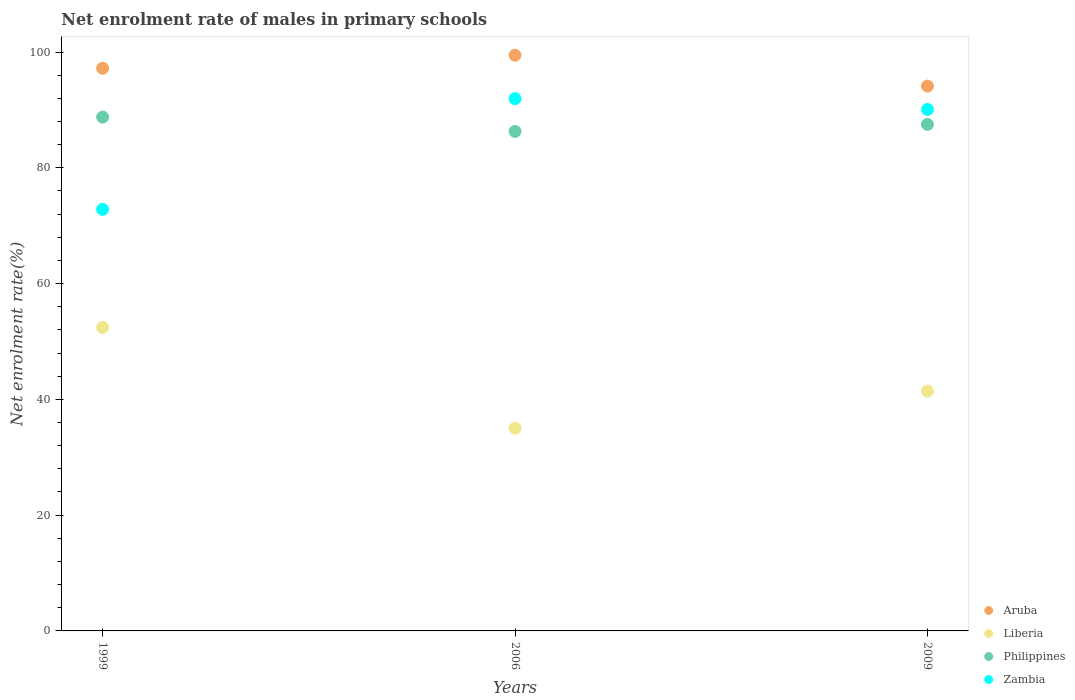How many different coloured dotlines are there?
Ensure brevity in your answer.  4. What is the net enrolment rate of males in primary schools in Liberia in 2009?
Provide a succinct answer. 41.44. Across all years, what is the maximum net enrolment rate of males in primary schools in Zambia?
Ensure brevity in your answer.  91.95. Across all years, what is the minimum net enrolment rate of males in primary schools in Liberia?
Give a very brief answer. 35.02. What is the total net enrolment rate of males in primary schools in Liberia in the graph?
Keep it short and to the point. 128.89. What is the difference between the net enrolment rate of males in primary schools in Zambia in 2006 and that in 2009?
Make the answer very short. 1.86. What is the difference between the net enrolment rate of males in primary schools in Liberia in 1999 and the net enrolment rate of males in primary schools in Zambia in 2009?
Your answer should be compact. -37.65. What is the average net enrolment rate of males in primary schools in Aruba per year?
Give a very brief answer. 96.93. In the year 1999, what is the difference between the net enrolment rate of males in primary schools in Zambia and net enrolment rate of males in primary schools in Aruba?
Your answer should be compact. -24.37. In how many years, is the net enrolment rate of males in primary schools in Aruba greater than 28 %?
Your response must be concise. 3. What is the ratio of the net enrolment rate of males in primary schools in Aruba in 2006 to that in 2009?
Offer a very short reply. 1.06. Is the net enrolment rate of males in primary schools in Philippines in 1999 less than that in 2006?
Your response must be concise. No. Is the difference between the net enrolment rate of males in primary schools in Zambia in 2006 and 2009 greater than the difference between the net enrolment rate of males in primary schools in Aruba in 2006 and 2009?
Your answer should be very brief. No. What is the difference between the highest and the second highest net enrolment rate of males in primary schools in Zambia?
Make the answer very short. 1.86. What is the difference between the highest and the lowest net enrolment rate of males in primary schools in Liberia?
Offer a very short reply. 17.41. Is it the case that in every year, the sum of the net enrolment rate of males in primary schools in Liberia and net enrolment rate of males in primary schools in Philippines  is greater than the sum of net enrolment rate of males in primary schools in Zambia and net enrolment rate of males in primary schools in Aruba?
Your response must be concise. No. Is the net enrolment rate of males in primary schools in Philippines strictly greater than the net enrolment rate of males in primary schools in Liberia over the years?
Your response must be concise. Yes. How many years are there in the graph?
Make the answer very short. 3. What is the difference between two consecutive major ticks on the Y-axis?
Provide a succinct answer. 20. Are the values on the major ticks of Y-axis written in scientific E-notation?
Make the answer very short. No. Does the graph contain grids?
Make the answer very short. No. Where does the legend appear in the graph?
Give a very brief answer. Bottom right. How many legend labels are there?
Your answer should be very brief. 4. What is the title of the graph?
Ensure brevity in your answer.  Net enrolment rate of males in primary schools. Does "American Samoa" appear as one of the legend labels in the graph?
Your answer should be very brief. No. What is the label or title of the X-axis?
Your answer should be compact. Years. What is the label or title of the Y-axis?
Give a very brief answer. Net enrolment rate(%). What is the Net enrolment rate(%) of Aruba in 1999?
Ensure brevity in your answer.  97.2. What is the Net enrolment rate(%) in Liberia in 1999?
Make the answer very short. 52.43. What is the Net enrolment rate(%) in Philippines in 1999?
Your answer should be very brief. 88.77. What is the Net enrolment rate(%) in Zambia in 1999?
Keep it short and to the point. 72.83. What is the Net enrolment rate(%) of Aruba in 2006?
Ensure brevity in your answer.  99.46. What is the Net enrolment rate(%) of Liberia in 2006?
Offer a terse response. 35.02. What is the Net enrolment rate(%) of Philippines in 2006?
Make the answer very short. 86.29. What is the Net enrolment rate(%) in Zambia in 2006?
Ensure brevity in your answer.  91.95. What is the Net enrolment rate(%) in Aruba in 2009?
Keep it short and to the point. 94.12. What is the Net enrolment rate(%) in Liberia in 2009?
Your response must be concise. 41.44. What is the Net enrolment rate(%) in Philippines in 2009?
Give a very brief answer. 87.5. What is the Net enrolment rate(%) in Zambia in 2009?
Give a very brief answer. 90.09. Across all years, what is the maximum Net enrolment rate(%) of Aruba?
Offer a terse response. 99.46. Across all years, what is the maximum Net enrolment rate(%) in Liberia?
Your answer should be compact. 52.43. Across all years, what is the maximum Net enrolment rate(%) of Philippines?
Provide a succinct answer. 88.77. Across all years, what is the maximum Net enrolment rate(%) of Zambia?
Keep it short and to the point. 91.95. Across all years, what is the minimum Net enrolment rate(%) of Aruba?
Your answer should be very brief. 94.12. Across all years, what is the minimum Net enrolment rate(%) in Liberia?
Provide a short and direct response. 35.02. Across all years, what is the minimum Net enrolment rate(%) in Philippines?
Ensure brevity in your answer.  86.29. Across all years, what is the minimum Net enrolment rate(%) of Zambia?
Give a very brief answer. 72.83. What is the total Net enrolment rate(%) of Aruba in the graph?
Offer a terse response. 290.78. What is the total Net enrolment rate(%) in Liberia in the graph?
Your response must be concise. 128.89. What is the total Net enrolment rate(%) in Philippines in the graph?
Your response must be concise. 262.57. What is the total Net enrolment rate(%) in Zambia in the graph?
Offer a terse response. 254.87. What is the difference between the Net enrolment rate(%) in Aruba in 1999 and that in 2006?
Offer a very short reply. -2.25. What is the difference between the Net enrolment rate(%) of Liberia in 1999 and that in 2006?
Offer a very short reply. 17.41. What is the difference between the Net enrolment rate(%) in Philippines in 1999 and that in 2006?
Offer a very short reply. 2.48. What is the difference between the Net enrolment rate(%) of Zambia in 1999 and that in 2006?
Offer a very short reply. -19.12. What is the difference between the Net enrolment rate(%) in Aruba in 1999 and that in 2009?
Ensure brevity in your answer.  3.08. What is the difference between the Net enrolment rate(%) in Liberia in 1999 and that in 2009?
Your answer should be compact. 10.99. What is the difference between the Net enrolment rate(%) in Philippines in 1999 and that in 2009?
Your answer should be compact. 1.27. What is the difference between the Net enrolment rate(%) in Zambia in 1999 and that in 2009?
Your answer should be compact. -17.25. What is the difference between the Net enrolment rate(%) of Aruba in 2006 and that in 2009?
Make the answer very short. 5.33. What is the difference between the Net enrolment rate(%) in Liberia in 2006 and that in 2009?
Offer a terse response. -6.42. What is the difference between the Net enrolment rate(%) in Philippines in 2006 and that in 2009?
Make the answer very short. -1.21. What is the difference between the Net enrolment rate(%) in Zambia in 2006 and that in 2009?
Provide a succinct answer. 1.86. What is the difference between the Net enrolment rate(%) of Aruba in 1999 and the Net enrolment rate(%) of Liberia in 2006?
Your response must be concise. 62.18. What is the difference between the Net enrolment rate(%) in Aruba in 1999 and the Net enrolment rate(%) in Philippines in 2006?
Provide a short and direct response. 10.91. What is the difference between the Net enrolment rate(%) of Aruba in 1999 and the Net enrolment rate(%) of Zambia in 2006?
Your answer should be compact. 5.25. What is the difference between the Net enrolment rate(%) of Liberia in 1999 and the Net enrolment rate(%) of Philippines in 2006?
Provide a succinct answer. -33.86. What is the difference between the Net enrolment rate(%) of Liberia in 1999 and the Net enrolment rate(%) of Zambia in 2006?
Your answer should be compact. -39.52. What is the difference between the Net enrolment rate(%) in Philippines in 1999 and the Net enrolment rate(%) in Zambia in 2006?
Provide a short and direct response. -3.18. What is the difference between the Net enrolment rate(%) of Aruba in 1999 and the Net enrolment rate(%) of Liberia in 2009?
Keep it short and to the point. 55.76. What is the difference between the Net enrolment rate(%) in Aruba in 1999 and the Net enrolment rate(%) in Philippines in 2009?
Your answer should be very brief. 9.7. What is the difference between the Net enrolment rate(%) in Aruba in 1999 and the Net enrolment rate(%) in Zambia in 2009?
Offer a terse response. 7.12. What is the difference between the Net enrolment rate(%) in Liberia in 1999 and the Net enrolment rate(%) in Philippines in 2009?
Your response must be concise. -35.07. What is the difference between the Net enrolment rate(%) in Liberia in 1999 and the Net enrolment rate(%) in Zambia in 2009?
Keep it short and to the point. -37.65. What is the difference between the Net enrolment rate(%) in Philippines in 1999 and the Net enrolment rate(%) in Zambia in 2009?
Keep it short and to the point. -1.31. What is the difference between the Net enrolment rate(%) in Aruba in 2006 and the Net enrolment rate(%) in Liberia in 2009?
Ensure brevity in your answer.  58.01. What is the difference between the Net enrolment rate(%) in Aruba in 2006 and the Net enrolment rate(%) in Philippines in 2009?
Keep it short and to the point. 11.95. What is the difference between the Net enrolment rate(%) of Aruba in 2006 and the Net enrolment rate(%) of Zambia in 2009?
Give a very brief answer. 9.37. What is the difference between the Net enrolment rate(%) of Liberia in 2006 and the Net enrolment rate(%) of Philippines in 2009?
Make the answer very short. -52.49. What is the difference between the Net enrolment rate(%) of Liberia in 2006 and the Net enrolment rate(%) of Zambia in 2009?
Make the answer very short. -55.07. What is the difference between the Net enrolment rate(%) in Philippines in 2006 and the Net enrolment rate(%) in Zambia in 2009?
Keep it short and to the point. -3.79. What is the average Net enrolment rate(%) in Aruba per year?
Provide a short and direct response. 96.93. What is the average Net enrolment rate(%) of Liberia per year?
Offer a terse response. 42.96. What is the average Net enrolment rate(%) of Philippines per year?
Provide a succinct answer. 87.52. What is the average Net enrolment rate(%) in Zambia per year?
Your response must be concise. 84.96. In the year 1999, what is the difference between the Net enrolment rate(%) of Aruba and Net enrolment rate(%) of Liberia?
Ensure brevity in your answer.  44.77. In the year 1999, what is the difference between the Net enrolment rate(%) in Aruba and Net enrolment rate(%) in Philippines?
Give a very brief answer. 8.43. In the year 1999, what is the difference between the Net enrolment rate(%) of Aruba and Net enrolment rate(%) of Zambia?
Provide a succinct answer. 24.37. In the year 1999, what is the difference between the Net enrolment rate(%) of Liberia and Net enrolment rate(%) of Philippines?
Your response must be concise. -36.34. In the year 1999, what is the difference between the Net enrolment rate(%) in Liberia and Net enrolment rate(%) in Zambia?
Provide a succinct answer. -20.4. In the year 1999, what is the difference between the Net enrolment rate(%) in Philippines and Net enrolment rate(%) in Zambia?
Make the answer very short. 15.94. In the year 2006, what is the difference between the Net enrolment rate(%) of Aruba and Net enrolment rate(%) of Liberia?
Your answer should be compact. 64.44. In the year 2006, what is the difference between the Net enrolment rate(%) of Aruba and Net enrolment rate(%) of Philippines?
Your answer should be compact. 13.16. In the year 2006, what is the difference between the Net enrolment rate(%) of Aruba and Net enrolment rate(%) of Zambia?
Provide a short and direct response. 7.51. In the year 2006, what is the difference between the Net enrolment rate(%) of Liberia and Net enrolment rate(%) of Philippines?
Provide a succinct answer. -51.27. In the year 2006, what is the difference between the Net enrolment rate(%) of Liberia and Net enrolment rate(%) of Zambia?
Keep it short and to the point. -56.93. In the year 2006, what is the difference between the Net enrolment rate(%) of Philippines and Net enrolment rate(%) of Zambia?
Keep it short and to the point. -5.66. In the year 2009, what is the difference between the Net enrolment rate(%) of Aruba and Net enrolment rate(%) of Liberia?
Make the answer very short. 52.68. In the year 2009, what is the difference between the Net enrolment rate(%) in Aruba and Net enrolment rate(%) in Philippines?
Make the answer very short. 6.62. In the year 2009, what is the difference between the Net enrolment rate(%) of Aruba and Net enrolment rate(%) of Zambia?
Your answer should be very brief. 4.04. In the year 2009, what is the difference between the Net enrolment rate(%) in Liberia and Net enrolment rate(%) in Philippines?
Offer a very short reply. -46.06. In the year 2009, what is the difference between the Net enrolment rate(%) in Liberia and Net enrolment rate(%) in Zambia?
Your answer should be very brief. -48.64. In the year 2009, what is the difference between the Net enrolment rate(%) in Philippines and Net enrolment rate(%) in Zambia?
Ensure brevity in your answer.  -2.58. What is the ratio of the Net enrolment rate(%) in Aruba in 1999 to that in 2006?
Your answer should be compact. 0.98. What is the ratio of the Net enrolment rate(%) of Liberia in 1999 to that in 2006?
Your answer should be compact. 1.5. What is the ratio of the Net enrolment rate(%) of Philippines in 1999 to that in 2006?
Make the answer very short. 1.03. What is the ratio of the Net enrolment rate(%) in Zambia in 1999 to that in 2006?
Ensure brevity in your answer.  0.79. What is the ratio of the Net enrolment rate(%) in Aruba in 1999 to that in 2009?
Make the answer very short. 1.03. What is the ratio of the Net enrolment rate(%) in Liberia in 1999 to that in 2009?
Your answer should be very brief. 1.27. What is the ratio of the Net enrolment rate(%) of Philippines in 1999 to that in 2009?
Offer a very short reply. 1.01. What is the ratio of the Net enrolment rate(%) of Zambia in 1999 to that in 2009?
Offer a very short reply. 0.81. What is the ratio of the Net enrolment rate(%) of Aruba in 2006 to that in 2009?
Your answer should be compact. 1.06. What is the ratio of the Net enrolment rate(%) of Liberia in 2006 to that in 2009?
Keep it short and to the point. 0.84. What is the ratio of the Net enrolment rate(%) of Philippines in 2006 to that in 2009?
Give a very brief answer. 0.99. What is the ratio of the Net enrolment rate(%) in Zambia in 2006 to that in 2009?
Make the answer very short. 1.02. What is the difference between the highest and the second highest Net enrolment rate(%) of Aruba?
Make the answer very short. 2.25. What is the difference between the highest and the second highest Net enrolment rate(%) of Liberia?
Provide a short and direct response. 10.99. What is the difference between the highest and the second highest Net enrolment rate(%) of Philippines?
Provide a short and direct response. 1.27. What is the difference between the highest and the second highest Net enrolment rate(%) of Zambia?
Give a very brief answer. 1.86. What is the difference between the highest and the lowest Net enrolment rate(%) in Aruba?
Provide a succinct answer. 5.33. What is the difference between the highest and the lowest Net enrolment rate(%) of Liberia?
Provide a succinct answer. 17.41. What is the difference between the highest and the lowest Net enrolment rate(%) of Philippines?
Ensure brevity in your answer.  2.48. What is the difference between the highest and the lowest Net enrolment rate(%) in Zambia?
Your answer should be compact. 19.12. 